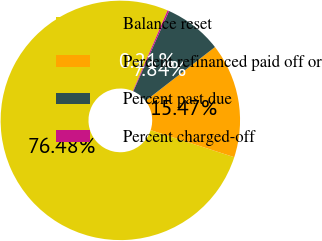Convert chart. <chart><loc_0><loc_0><loc_500><loc_500><pie_chart><fcel>Balance reset<fcel>Percent refinanced paid off or<fcel>Percent past due<fcel>Percent charged-off<nl><fcel>76.49%<fcel>15.47%<fcel>7.84%<fcel>0.21%<nl></chart> 